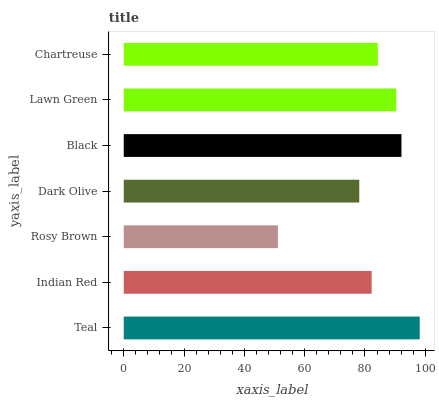Is Rosy Brown the minimum?
Answer yes or no. Yes. Is Teal the maximum?
Answer yes or no. Yes. Is Indian Red the minimum?
Answer yes or no. No. Is Indian Red the maximum?
Answer yes or no. No. Is Teal greater than Indian Red?
Answer yes or no. Yes. Is Indian Red less than Teal?
Answer yes or no. Yes. Is Indian Red greater than Teal?
Answer yes or no. No. Is Teal less than Indian Red?
Answer yes or no. No. Is Chartreuse the high median?
Answer yes or no. Yes. Is Chartreuse the low median?
Answer yes or no. Yes. Is Rosy Brown the high median?
Answer yes or no. No. Is Teal the low median?
Answer yes or no. No. 